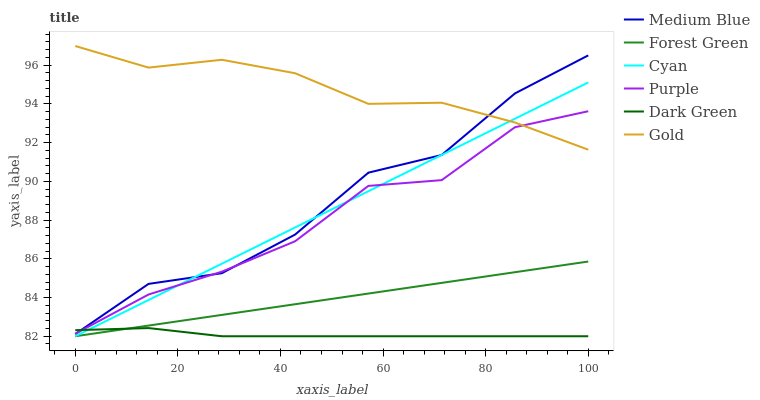Does Purple have the minimum area under the curve?
Answer yes or no. No. Does Purple have the maximum area under the curve?
Answer yes or no. No. Is Purple the smoothest?
Answer yes or no. No. Is Purple the roughest?
Answer yes or no. No. Does Purple have the lowest value?
Answer yes or no. No. Does Purple have the highest value?
Answer yes or no. No. Is Dark Green less than Gold?
Answer yes or no. Yes. Is Medium Blue greater than Forest Green?
Answer yes or no. Yes. Does Dark Green intersect Gold?
Answer yes or no. No. 